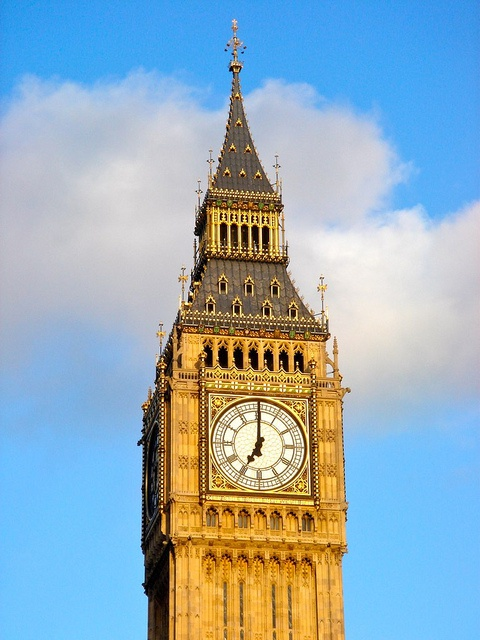Describe the objects in this image and their specific colors. I can see clock in gray, beige, khaki, tan, and maroon tones and clock in gray and black tones in this image. 